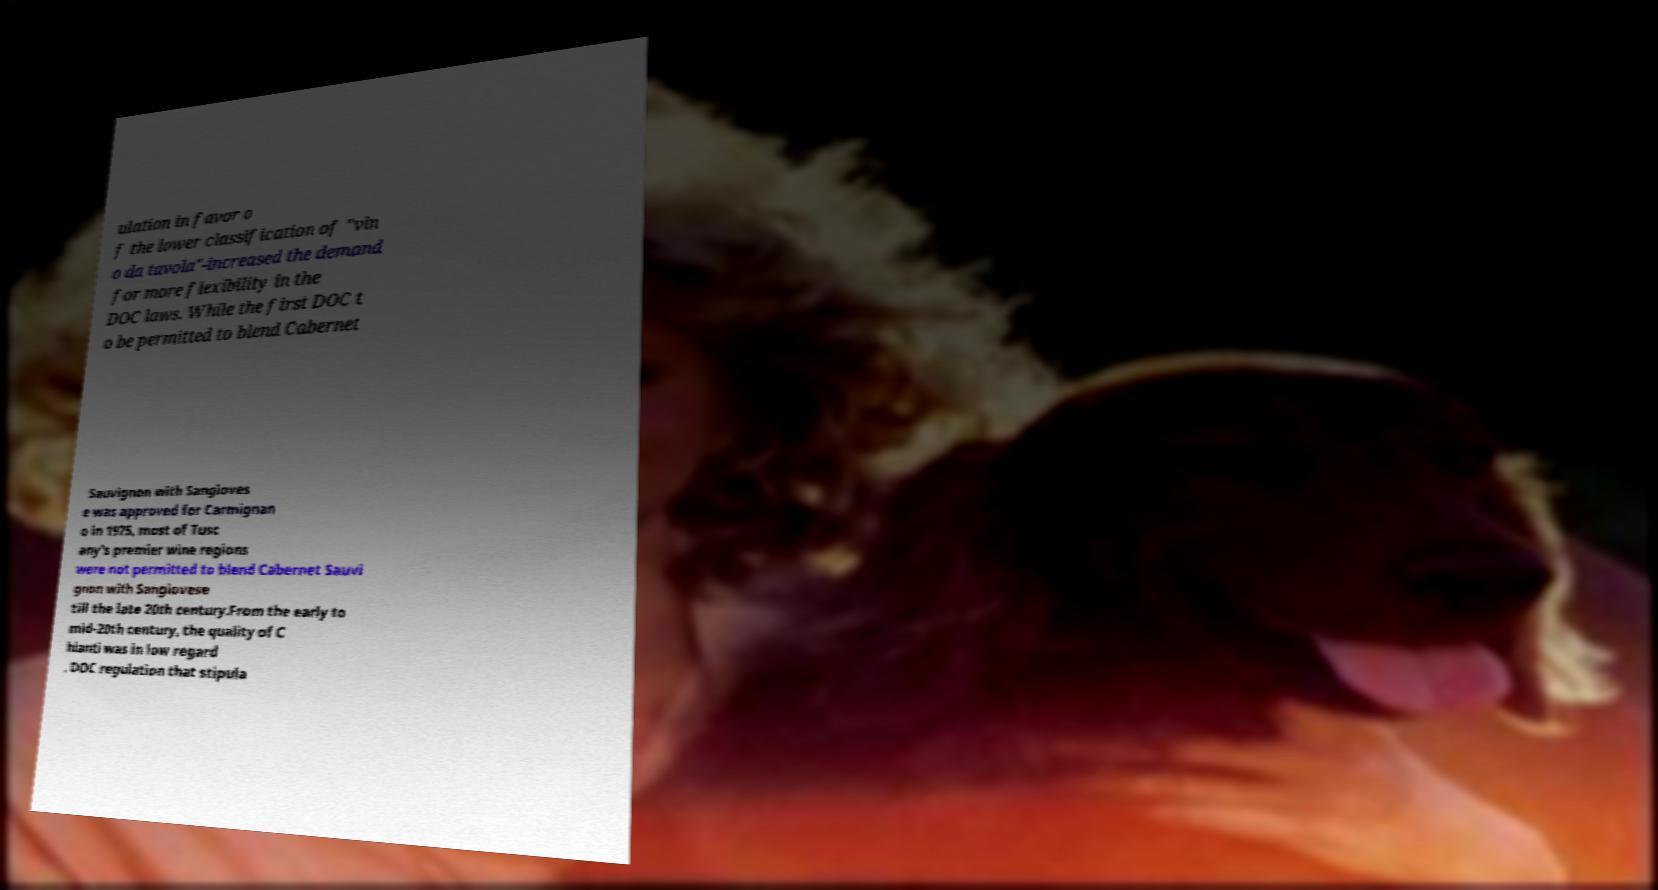I need the written content from this picture converted into text. Can you do that? ulation in favor o f the lower classification of "vin o da tavola"-increased the demand for more flexibility in the DOC laws. While the first DOC t o be permitted to blend Cabernet Sauvignon with Sangioves e was approved for Carmignan o in 1975, most of Tusc any's premier wine regions were not permitted to blend Cabernet Sauvi gnon with Sangiovese till the late 20th century.From the early to mid-20th century, the quality of C hianti was in low regard . DOC regulation that stipula 